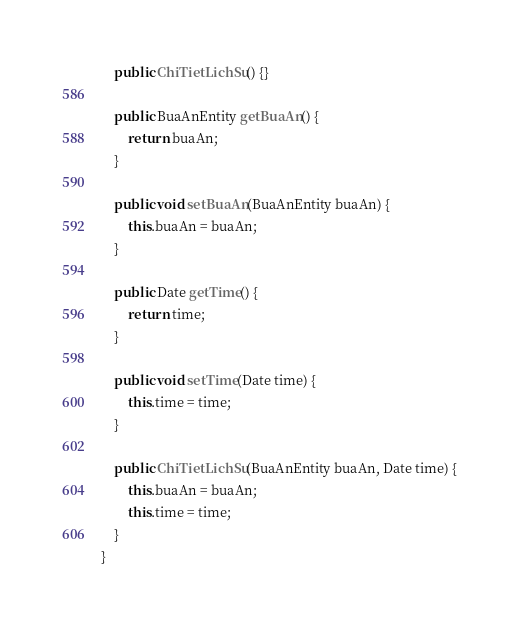Convert code to text. <code><loc_0><loc_0><loc_500><loc_500><_Java_>    public ChiTietLichSu() {}

    public BuaAnEntity getBuaAn() {
        return buaAn;
    }

    public void setBuaAn(BuaAnEntity buaAn) {
        this.buaAn = buaAn;
    }

    public Date getTime() {
        return time;
    }

    public void setTime(Date time) {
        this.time = time;
    }

    public ChiTietLichSu(BuaAnEntity buaAn, Date time) {
        this.buaAn = buaAn;
        this.time = time;
    }
}
</code> 